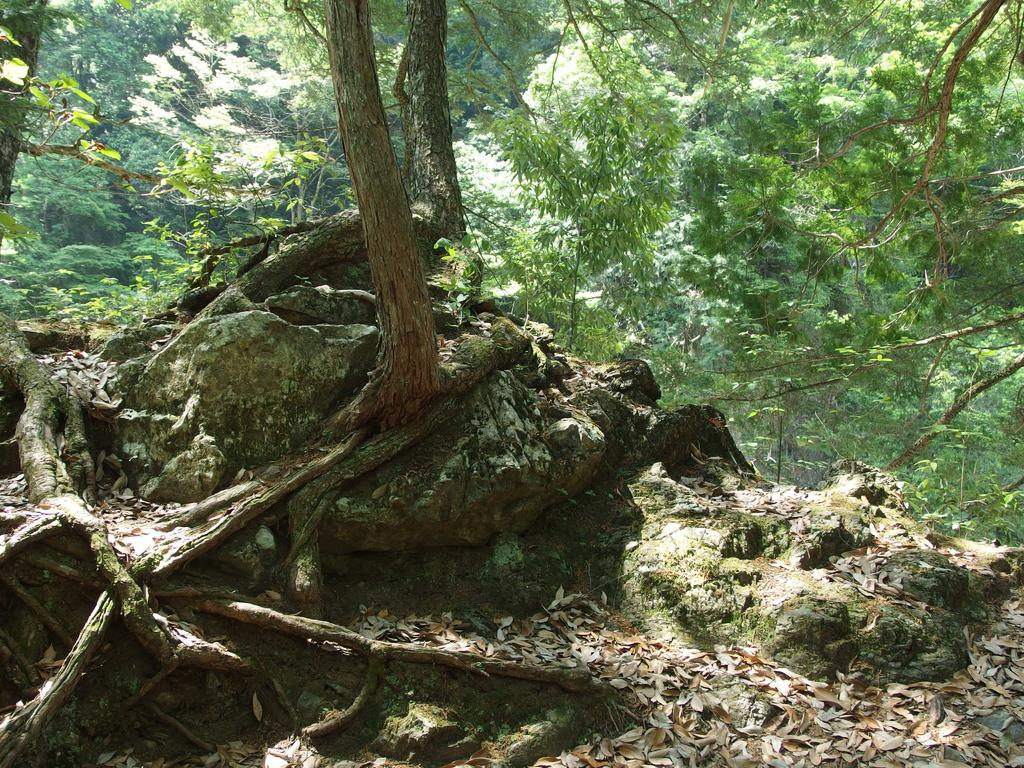What type of vegetation can be seen in the image? There are many trees in the image. What other natural elements are present in the image? There are rocks in the image. What can be found on the ground among the trees and rocks? Dried twigs are present on the ground in the image. How many loaves of bread can be seen in the image? There are no loaves of bread present in the image. What type of animals can be seen among the trees and rocks in the image? There are no animals, including rabbits, present in the image. 